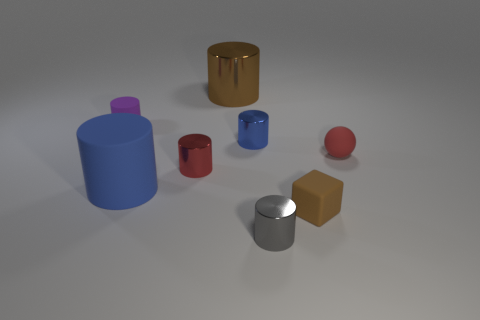There is a tiny red rubber object; how many tiny rubber things are in front of it?
Offer a very short reply. 1. Does the cylinder in front of the cube have the same color as the block?
Your answer should be compact. No. What number of gray things are either rubber blocks or large blocks?
Provide a short and direct response. 0. There is a large object to the right of the large object that is left of the small red metal object; what is its color?
Make the answer very short. Brown. What is the material of the small cylinder that is the same color as the large rubber object?
Make the answer very short. Metal. What color is the matte cylinder that is behind the blue matte thing?
Provide a short and direct response. Purple. Is the size of the red object that is right of the block the same as the small purple cylinder?
Your answer should be compact. Yes. The cylinder that is the same color as the sphere is what size?
Your response must be concise. Small. Is there a purple thing that has the same size as the matte ball?
Offer a very short reply. Yes. There is a small shiny thing in front of the block; is it the same color as the rubber cylinder that is in front of the tiny red matte sphere?
Your answer should be very brief. No. 